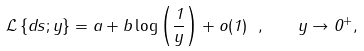<formula> <loc_0><loc_0><loc_500><loc_500>\mathcal { L } \left \{ d s ; y \right \} = a + b \log \left ( \frac { 1 } { y } \right ) + o ( 1 ) \ , \quad y \rightarrow 0 ^ { + } ,</formula> 